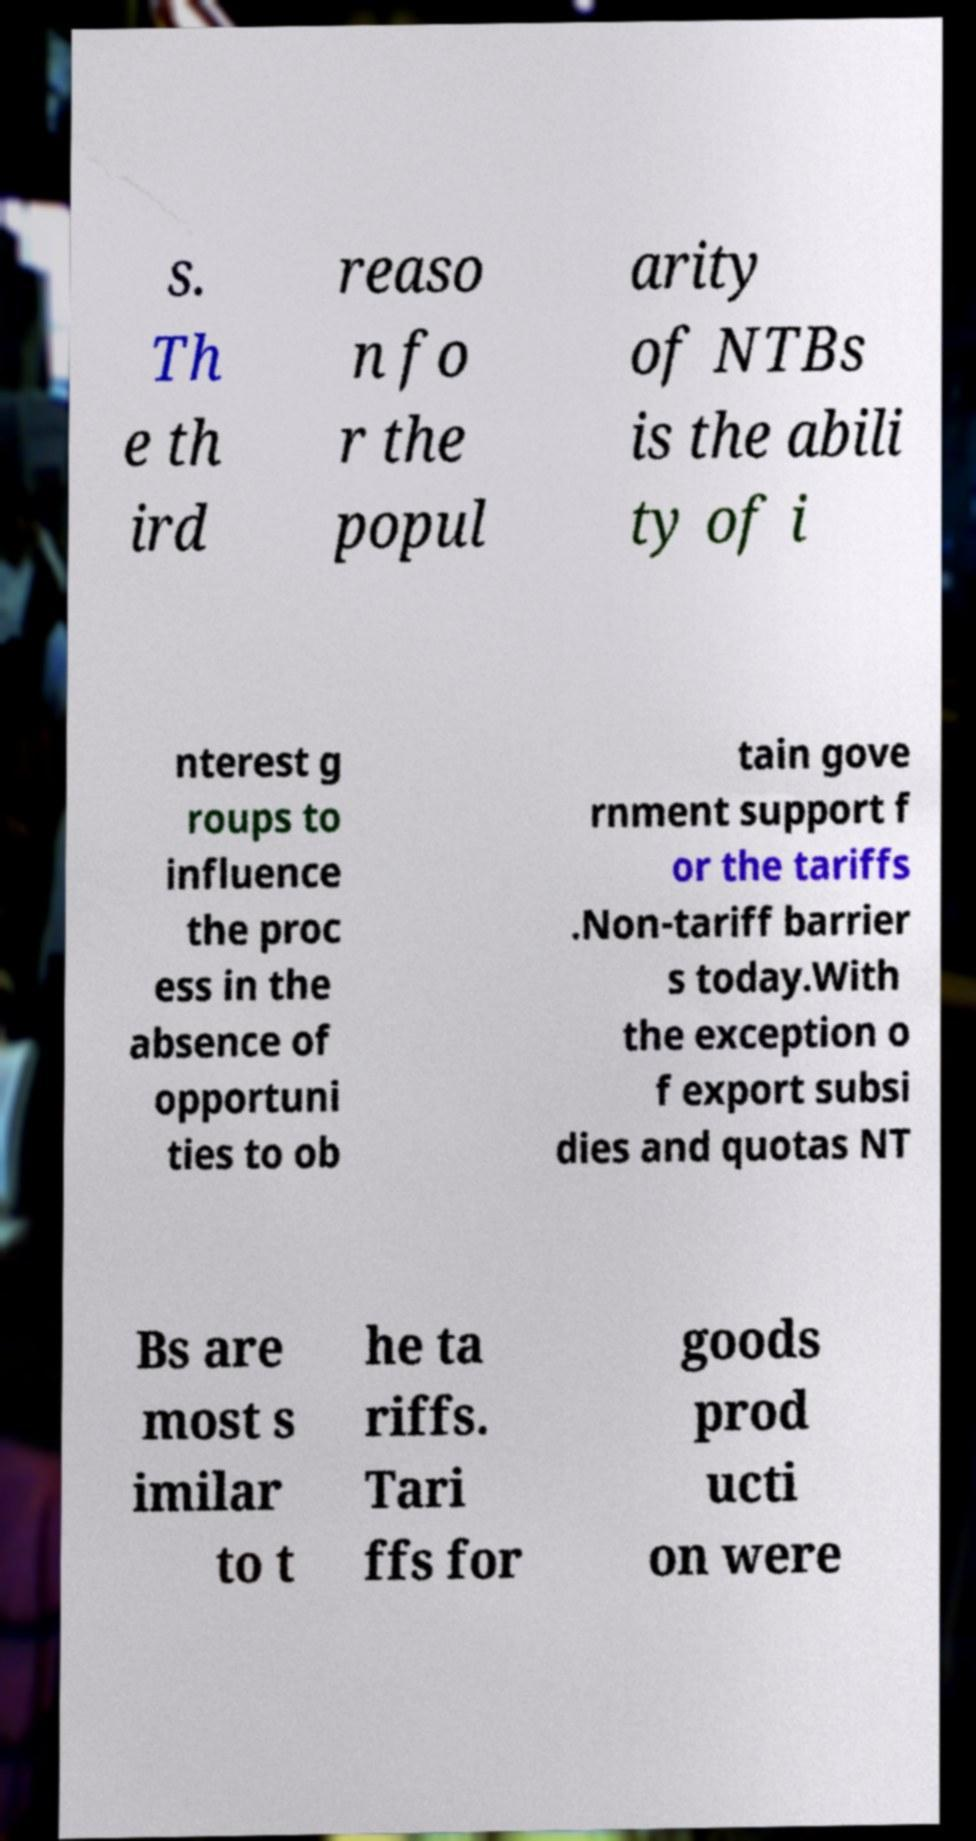Can you accurately transcribe the text from the provided image for me? s. Th e th ird reaso n fo r the popul arity of NTBs is the abili ty of i nterest g roups to influence the proc ess in the absence of opportuni ties to ob tain gove rnment support f or the tariffs .Non-tariff barrier s today.With the exception o f export subsi dies and quotas NT Bs are most s imilar to t he ta riffs. Tari ffs for goods prod ucti on were 